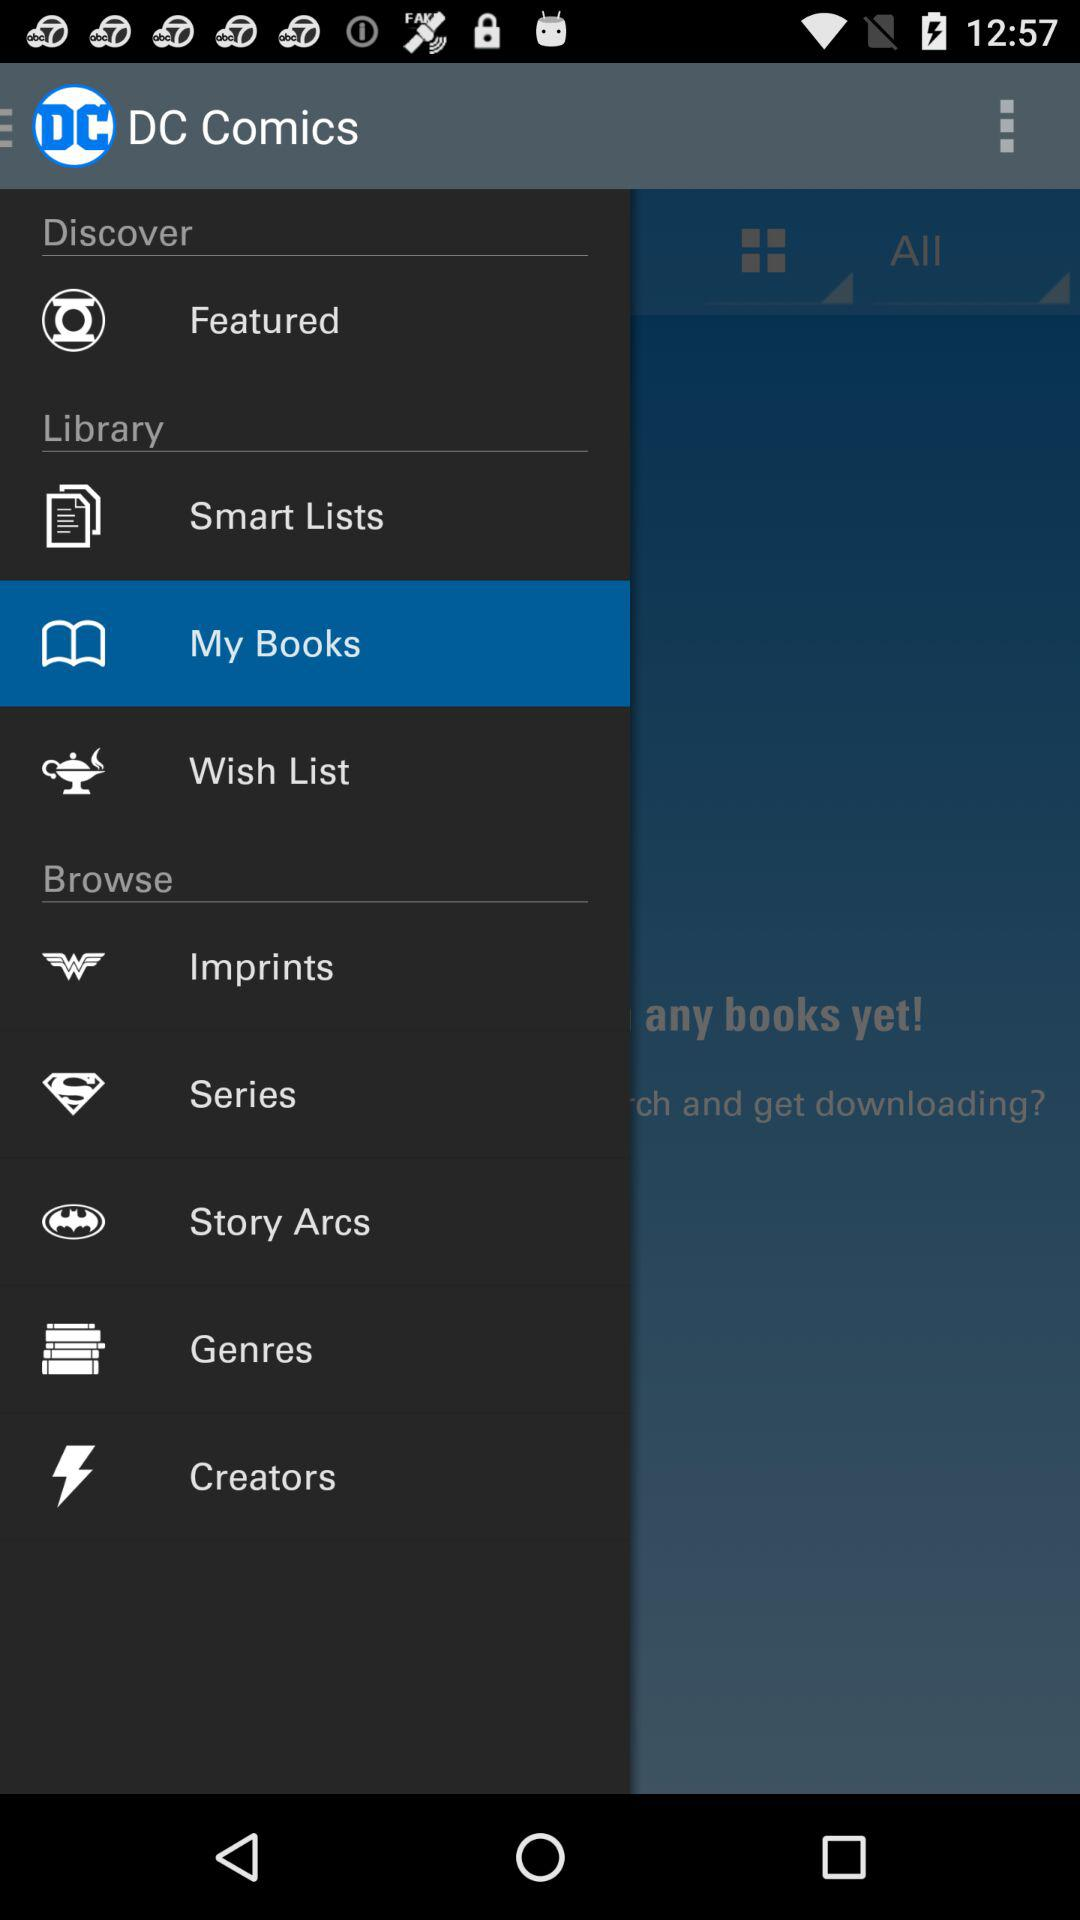What is the application name? The application name is "DC Comics". 